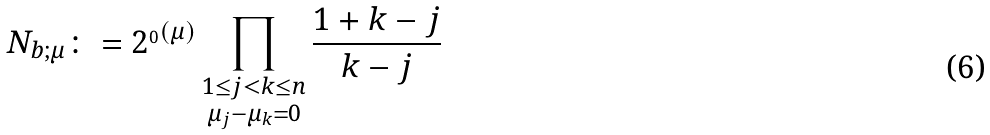Convert formula to latex. <formula><loc_0><loc_0><loc_500><loc_500>N _ { b ; \mu } \colon = 2 ^ { _ { 0 } ( \mu ) } \prod _ { \substack { 1 \leq j < k \leq n \\ \mu _ { j } - \mu _ { k } = 0 } } \frac { 1 + k - j } { k - j }</formula> 